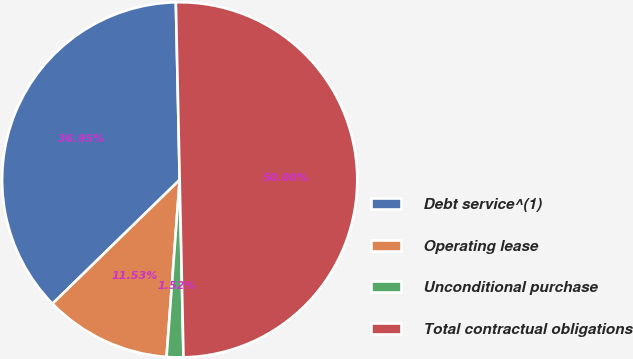<chart> <loc_0><loc_0><loc_500><loc_500><pie_chart><fcel>Debt service^(1)<fcel>Operating lease<fcel>Unconditional purchase<fcel>Total contractual obligations<nl><fcel>36.95%<fcel>11.53%<fcel>1.52%<fcel>50.0%<nl></chart> 